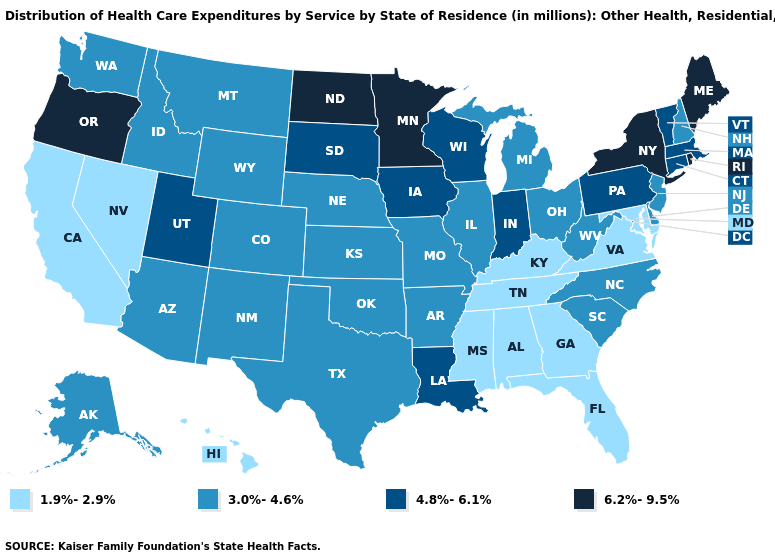Does Wyoming have a lower value than Vermont?
Keep it brief. Yes. Is the legend a continuous bar?
Quick response, please. No. Name the states that have a value in the range 3.0%-4.6%?
Answer briefly. Alaska, Arizona, Arkansas, Colorado, Delaware, Idaho, Illinois, Kansas, Michigan, Missouri, Montana, Nebraska, New Hampshire, New Jersey, New Mexico, North Carolina, Ohio, Oklahoma, South Carolina, Texas, Washington, West Virginia, Wyoming. What is the value of Connecticut?
Keep it brief. 4.8%-6.1%. Does Alabama have the same value as Iowa?
Be succinct. No. Does Wyoming have the lowest value in the West?
Give a very brief answer. No. What is the lowest value in the USA?
Quick response, please. 1.9%-2.9%. Name the states that have a value in the range 3.0%-4.6%?
Give a very brief answer. Alaska, Arizona, Arkansas, Colorado, Delaware, Idaho, Illinois, Kansas, Michigan, Missouri, Montana, Nebraska, New Hampshire, New Jersey, New Mexico, North Carolina, Ohio, Oklahoma, South Carolina, Texas, Washington, West Virginia, Wyoming. What is the highest value in the USA?
Concise answer only. 6.2%-9.5%. Does Washington have the highest value in the USA?
Keep it brief. No. What is the value of Iowa?
Answer briefly. 4.8%-6.1%. Is the legend a continuous bar?
Short answer required. No. Among the states that border Minnesota , does North Dakota have the highest value?
Answer briefly. Yes. What is the value of Mississippi?
Answer briefly. 1.9%-2.9%. Does the map have missing data?
Concise answer only. No. 